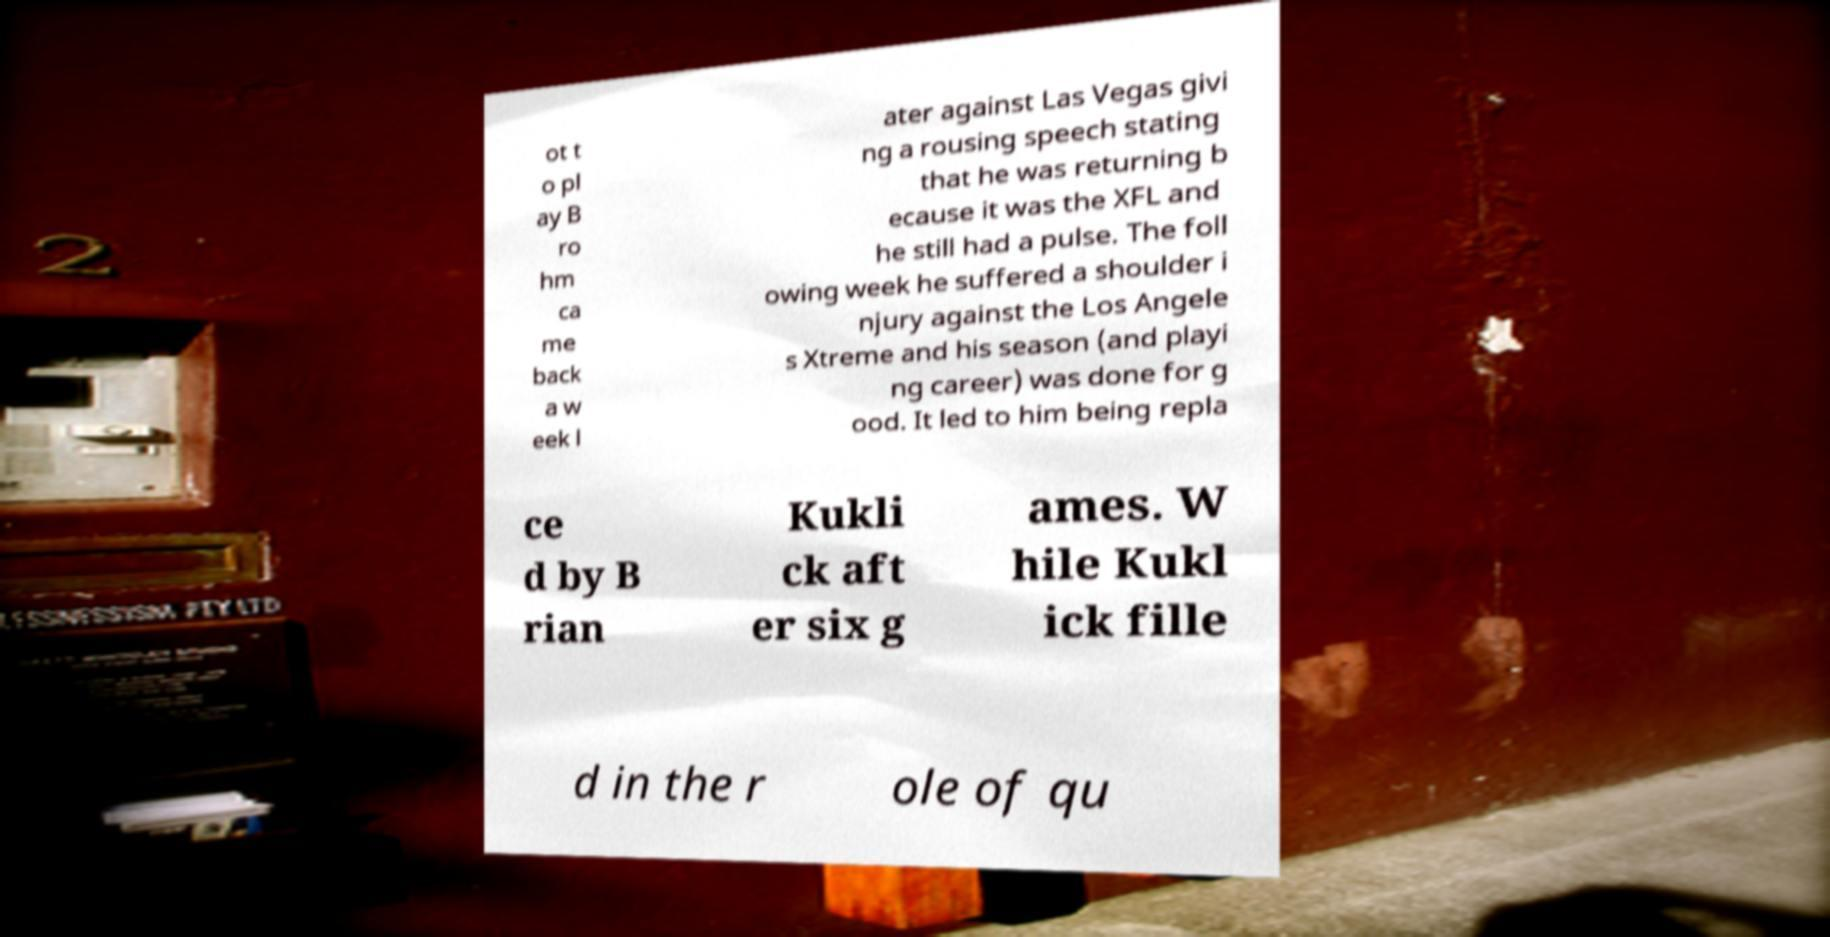Please read and relay the text visible in this image. What does it say? ot t o pl ay B ro hm ca me back a w eek l ater against Las Vegas givi ng a rousing speech stating that he was returning b ecause it was the XFL and he still had a pulse. The foll owing week he suffered a shoulder i njury against the Los Angele s Xtreme and his season (and playi ng career) was done for g ood. It led to him being repla ce d by B rian Kukli ck aft er six g ames. W hile Kukl ick fille d in the r ole of qu 